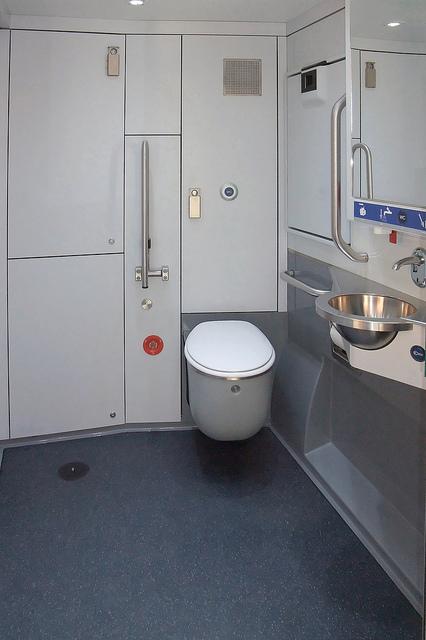Is this a home bathroom?
Concise answer only. No. Is this within a mobile object?
Quick response, please. Yes. Are there handles for people to steady themselves with?
Write a very short answer. Yes. 